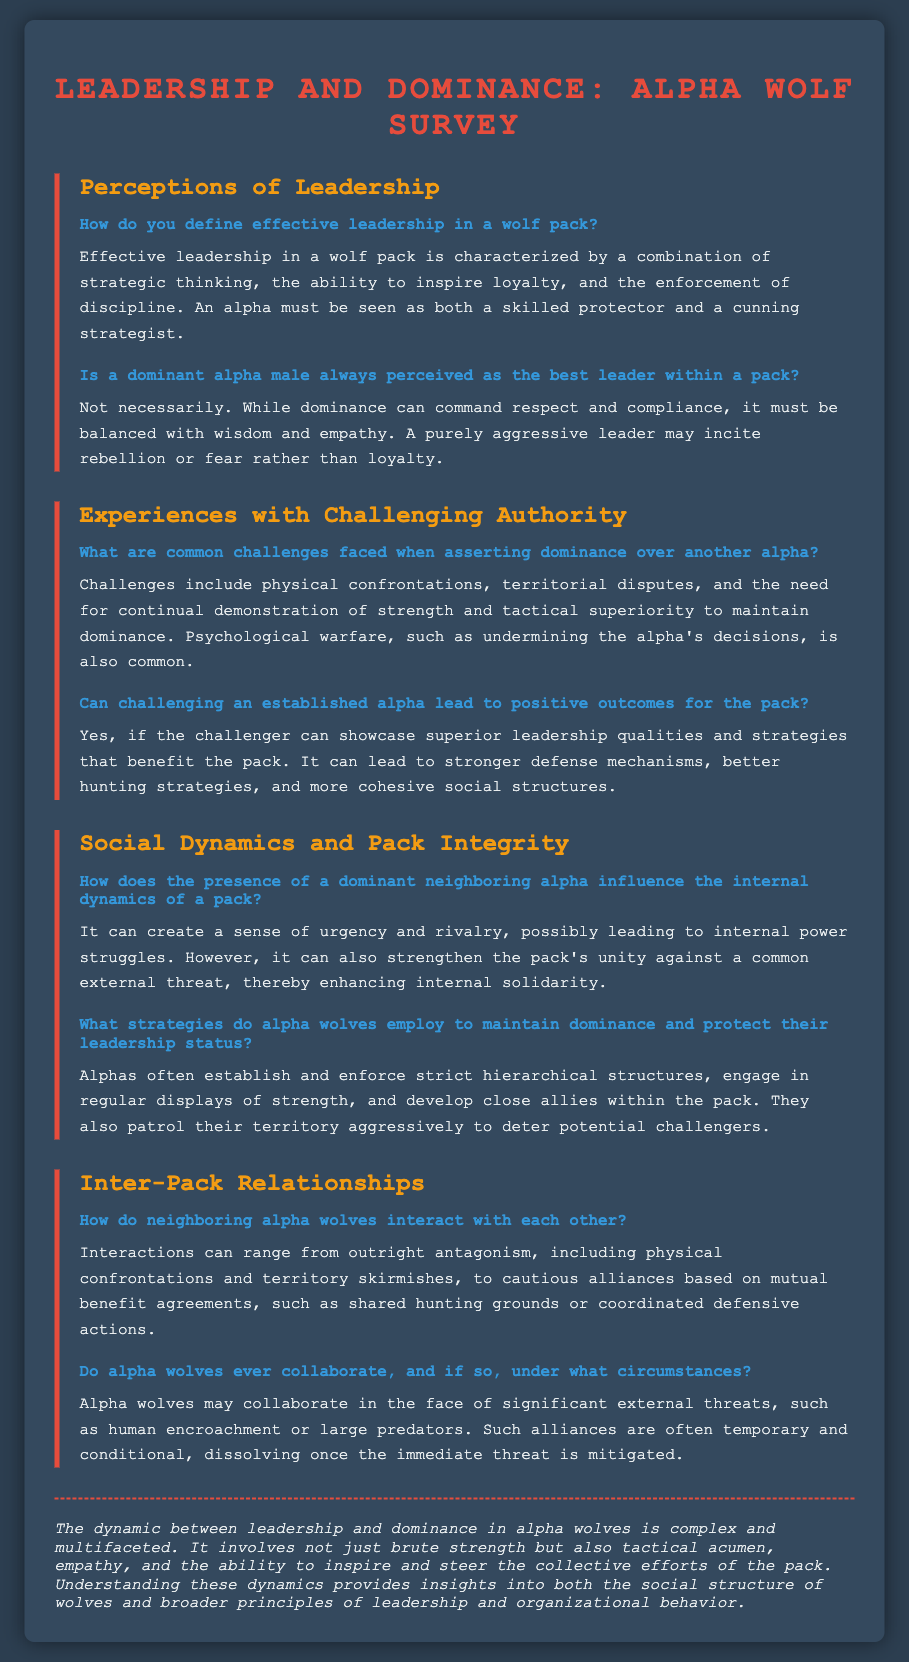what is the title of the survey? The title of the survey is displayed prominently at the top of the document and sets the theme for the content.
Answer: Alpha Wolf Leadership Survey how is effective leadership defined in a wolf pack? The definition of effective leadership is provided under the section on Perceptions of Leadership, emphasizing strategic thinking and inspiring loyalty.
Answer: Strategic thinking, ability to inspire loyalty, enforcement of discipline is a dominant alpha male always the best leader? This question is addressed directly in the document, discussing the qualities required for effective leadership.
Answer: Not necessarily what challenges are faced when asserting dominance over another alpha? The document lists various challenges encountered in this context, found in the section on Experiences with Challenging Authority.
Answer: Physical confrontations, territorial disputes how do neighboring alpha wolves interact? The interactions of neighboring alpha wolves are described in the section on Inter-Pack Relationships, outlining different types of relations.
Answer: Antagonism, cautious alliances what can a challenger to an alpha achieve? This is discussed in the Experiences with Challenging Authority section, where the potential outcomes of challenging an alpha are mentioned.
Answer: Positive outcomes for the pack what strategies do alpha wolves use to maintain dominance? The document specifies strategies employed by alpha wolves in the Social Dynamics and Pack Integrity section.
Answer: Establish strict hierarchical structures, displays of strength who does the alpha collaborate with in case of threats? Information regarding collaborations in the context of threats is provided in the Inter-Pack Relationships section.
Answer: Other alpha wolves what type of document is this? The nature of the document is indicated by its content and design, characterized by a set of survey questions and responses.
Answer: Survey form 